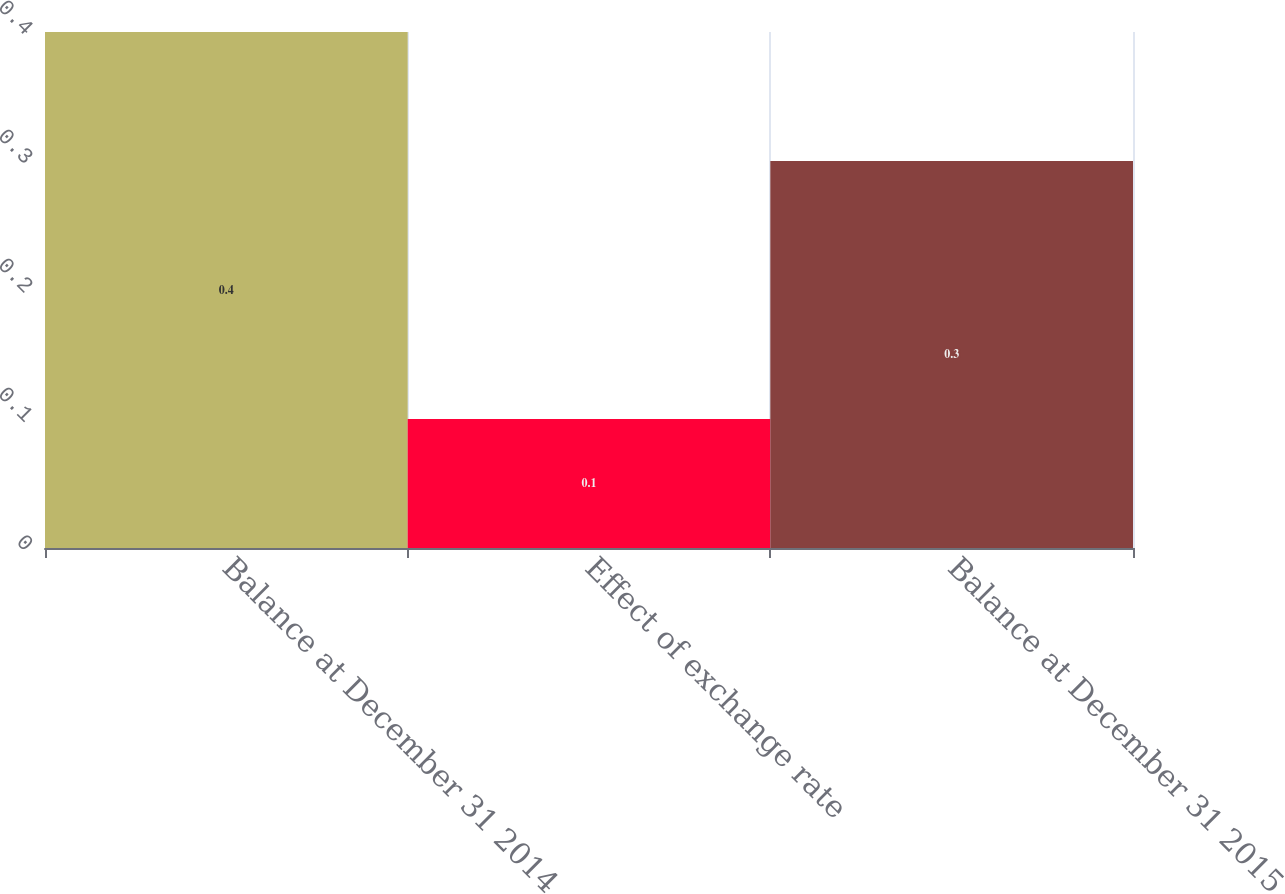Convert chart to OTSL. <chart><loc_0><loc_0><loc_500><loc_500><bar_chart><fcel>Balance at December 31 2014<fcel>Effect of exchange rate<fcel>Balance at December 31 2015<nl><fcel>0.4<fcel>0.1<fcel>0.3<nl></chart> 